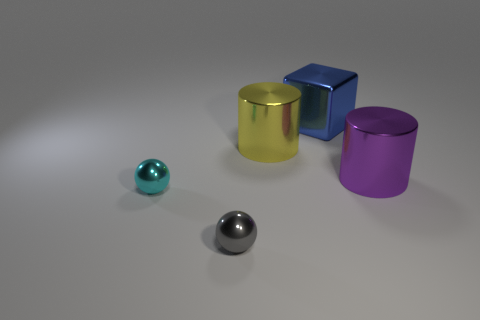Are there any other things that have the same shape as the blue metal object?
Your answer should be very brief. No. Does the thing that is to the right of the blue metallic cube have the same material as the tiny object that is in front of the cyan metallic thing?
Keep it short and to the point. Yes. What is the color of the cube?
Offer a terse response. Blue. There is a thing left of the small thing that is in front of the tiny object left of the gray metallic sphere; what is its size?
Your answer should be compact. Small. How many other objects are the same size as the cyan metal sphere?
Keep it short and to the point. 1. What number of large blue things have the same material as the large purple cylinder?
Your answer should be compact. 1. What is the shape of the tiny thing in front of the tiny cyan sphere?
Your answer should be compact. Sphere. Is the purple cylinder made of the same material as the large cylinder that is on the left side of the large purple metallic thing?
Ensure brevity in your answer.  Yes. Is there a blue matte sphere?
Make the answer very short. No. There is a tiny cyan shiny thing left of the large metallic cylinder that is on the right side of the blue cube; are there any objects that are to the right of it?
Keep it short and to the point. Yes. 